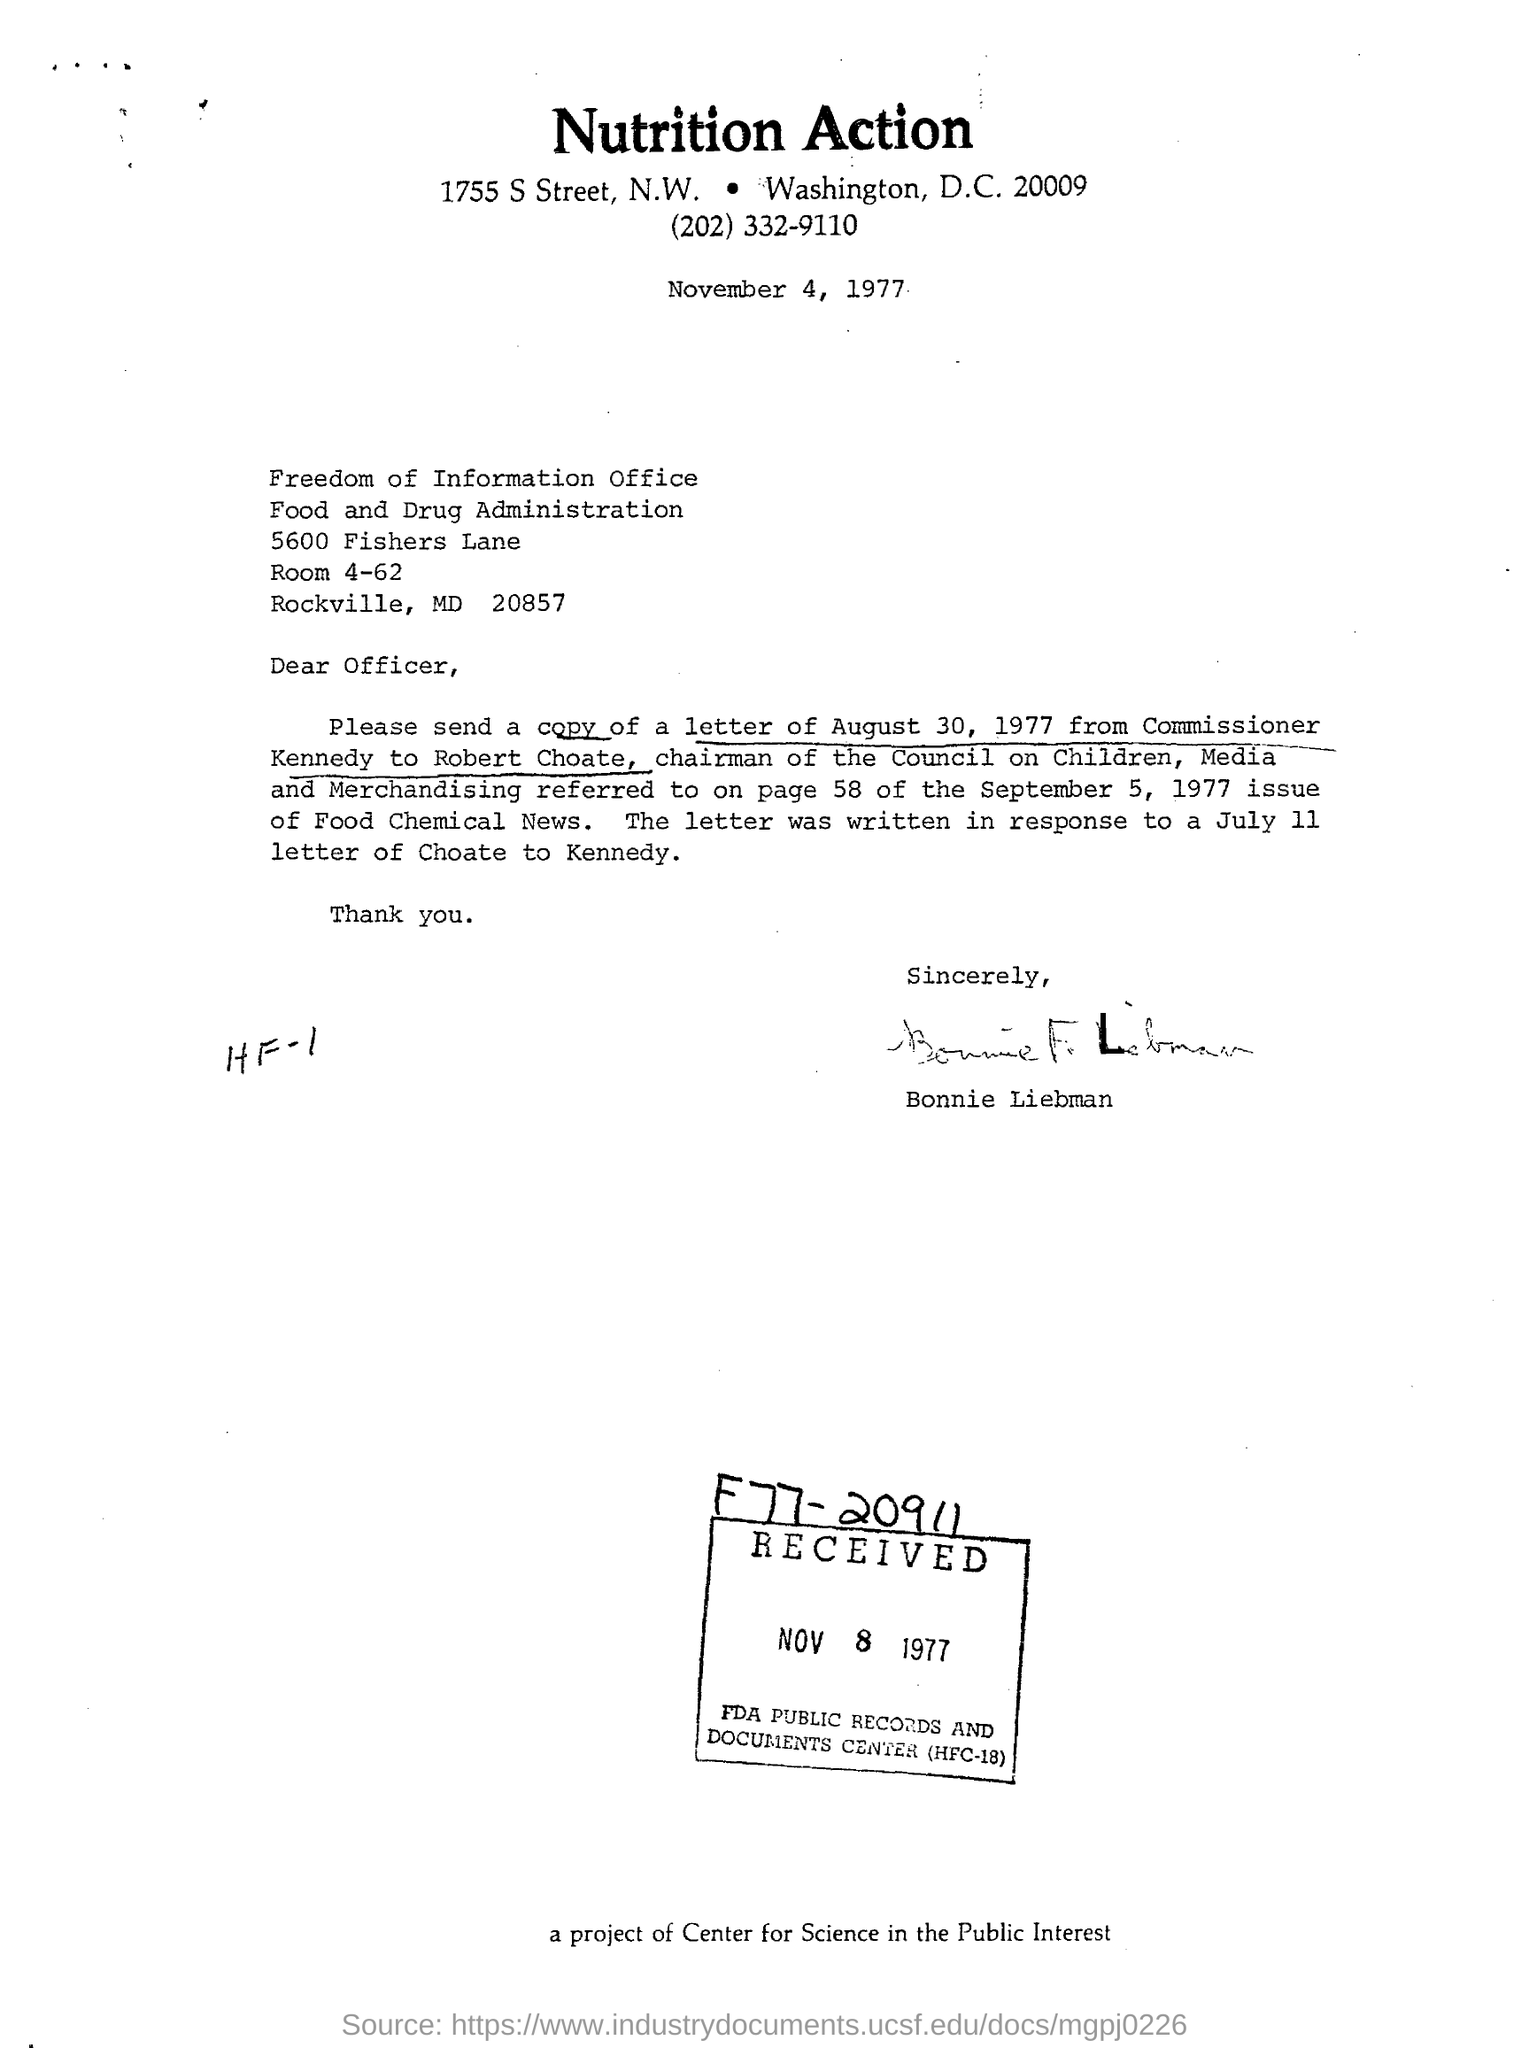Draw attention to some important aspects in this diagram. The name of the office mentioned in the letter is the Freedom of Information office. The letter has been signed by Bonnie Liebman. The chairman of the council on children, media and merchandising is Robert Choate. The heading of the document is 'Nutrition Action.' 